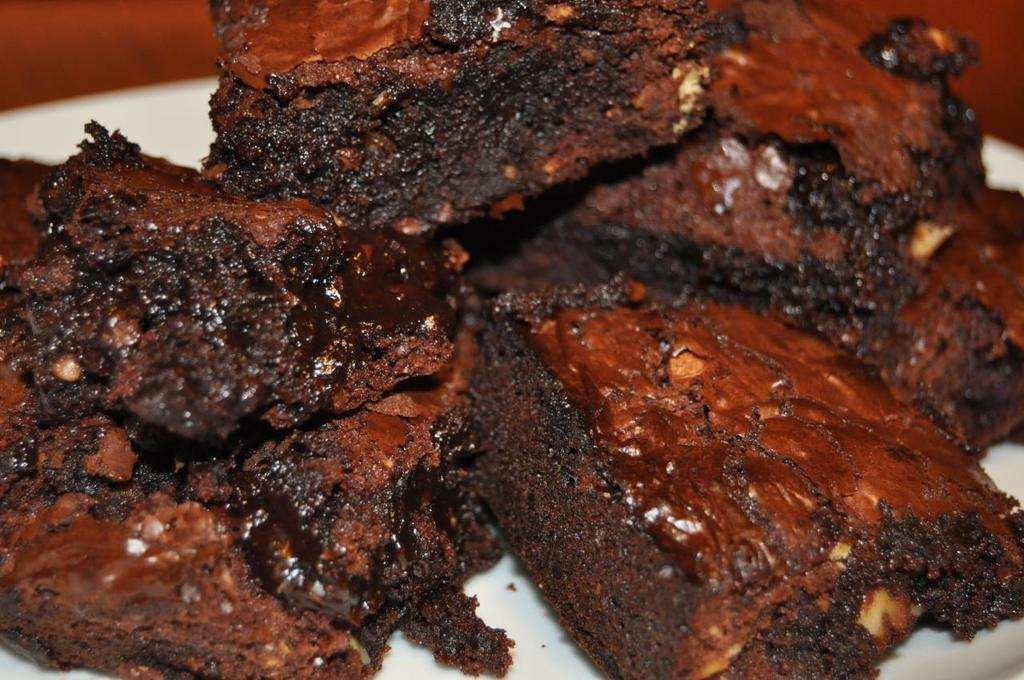What is present on the plate in the image? There are food items on a plate in the image. What type of secretary can be seen performing an activity in the image? There is no secretary or any activity involving a secretary present in the image. 